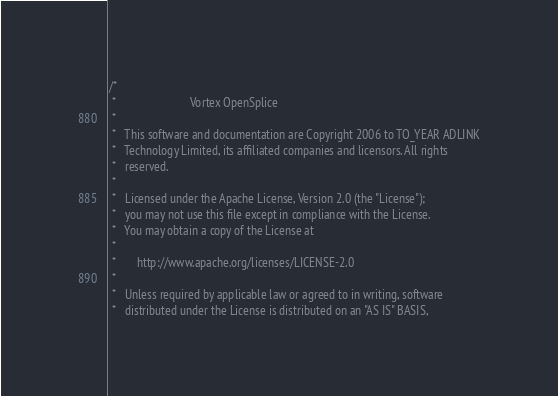Convert code to text. <code><loc_0><loc_0><loc_500><loc_500><_C_>/*
 *                         Vortex OpenSplice
 *
 *   This software and documentation are Copyright 2006 to TO_YEAR ADLINK
 *   Technology Limited, its affiliated companies and licensors. All rights
 *   reserved.
 *
 *   Licensed under the Apache License, Version 2.0 (the "License");
 *   you may not use this file except in compliance with the License.
 *   You may obtain a copy of the License at
 *
 *       http://www.apache.org/licenses/LICENSE-2.0
 *
 *   Unless required by applicable law or agreed to in writing, software
 *   distributed under the License is distributed on an "AS IS" BASIS,</code> 